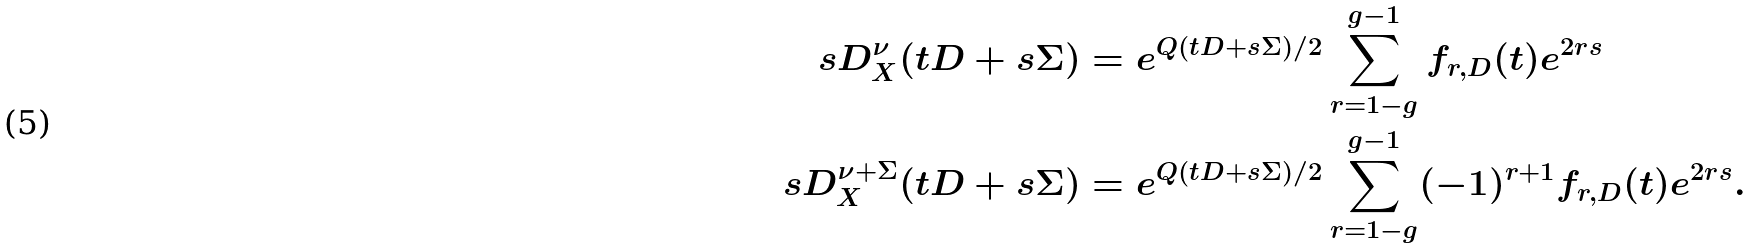<formula> <loc_0><loc_0><loc_500><loc_500>\ s D _ { X } ^ { \nu } ( t D + s \Sigma ) & = e ^ { Q ( t D + s \Sigma ) / 2 } \sum _ { r = 1 - g } ^ { g - 1 } f _ { r , D } ( t ) e ^ { 2 r s } \\ \ s D _ { X } ^ { \nu + \Sigma } ( t D + s \Sigma ) & = e ^ { Q ( t D + s \Sigma ) / 2 } \sum _ { r = 1 - g } ^ { g - 1 } ( - 1 ) ^ { r + 1 } f _ { r , D } ( t ) e ^ { 2 r s } .</formula> 